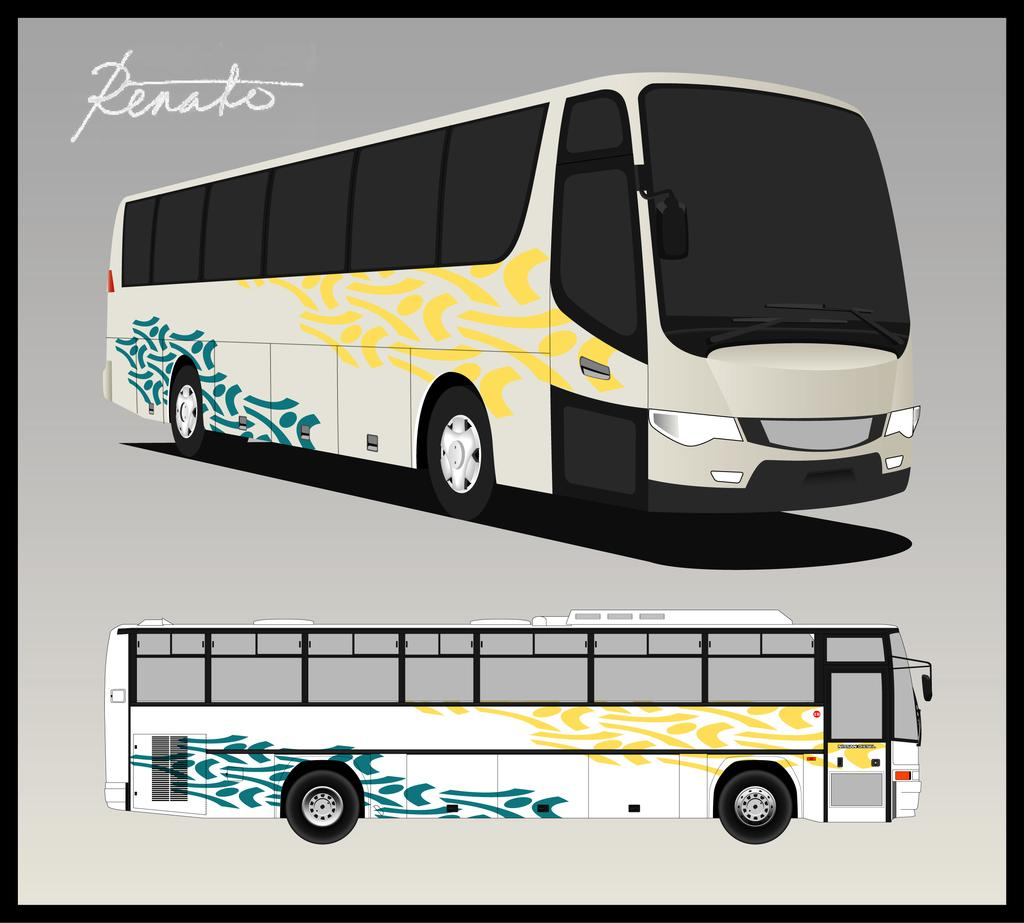Provide a one-sentence caption for the provided image. A drawing of a bus with the caption Renato. 